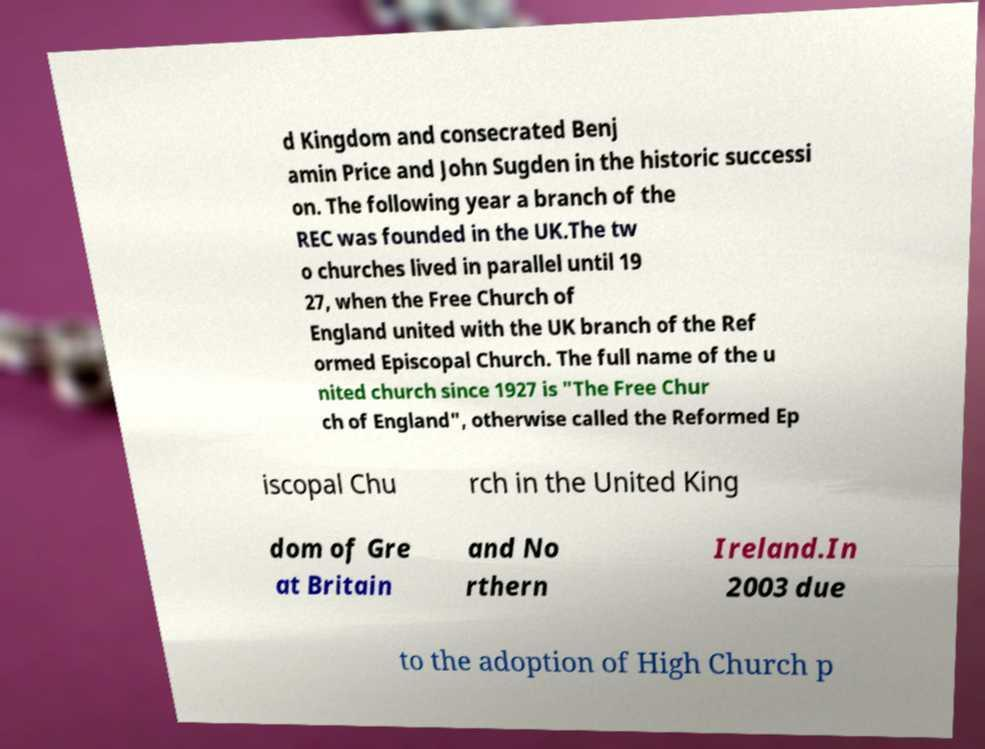Could you extract and type out the text from this image? d Kingdom and consecrated Benj amin Price and John Sugden in the historic successi on. The following year a branch of the REC was founded in the UK.The tw o churches lived in parallel until 19 27, when the Free Church of England united with the UK branch of the Ref ormed Episcopal Church. The full name of the u nited church since 1927 is "The Free Chur ch of England", otherwise called the Reformed Ep iscopal Chu rch in the United King dom of Gre at Britain and No rthern Ireland.In 2003 due to the adoption of High Church p 